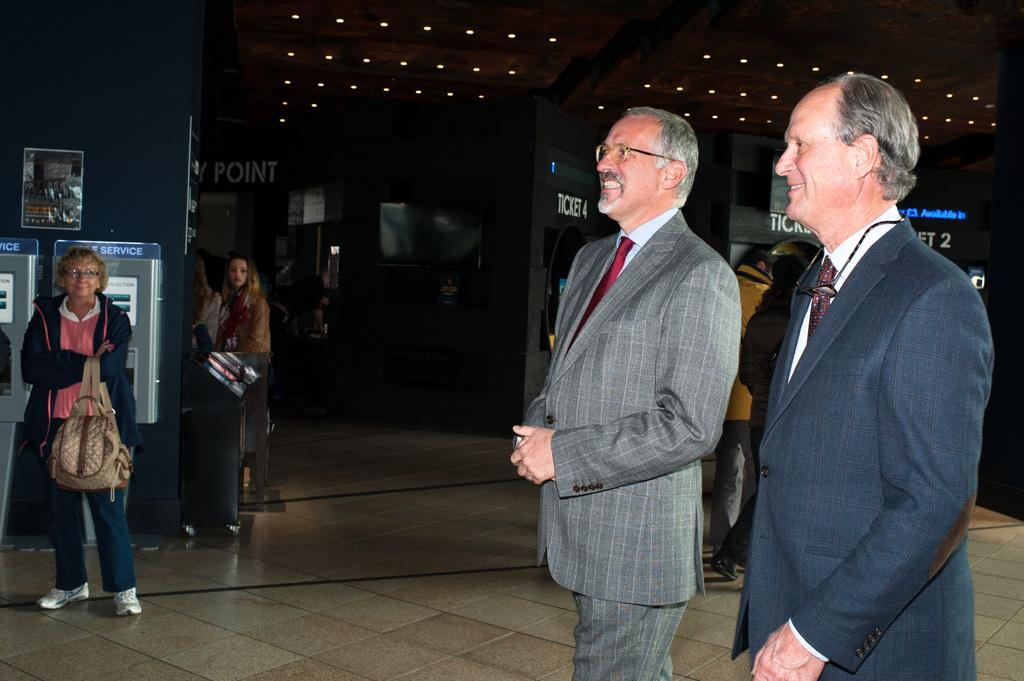What type of location is depicted in the image? The image is an inside view of a building. What can be seen on the floor in the image? There are people standing on the floor in the image. What type of service is provided at the counters in the image? There are ticket counters in the image, which suggests that tickets are being sold or provided. What type of lighting is used in the image? There are ceiling lights visible in the image. Can you describe the bee buzzing around the mouth of one of the people in the image? There is no bee present in the image, and no one's mouth is visible. 